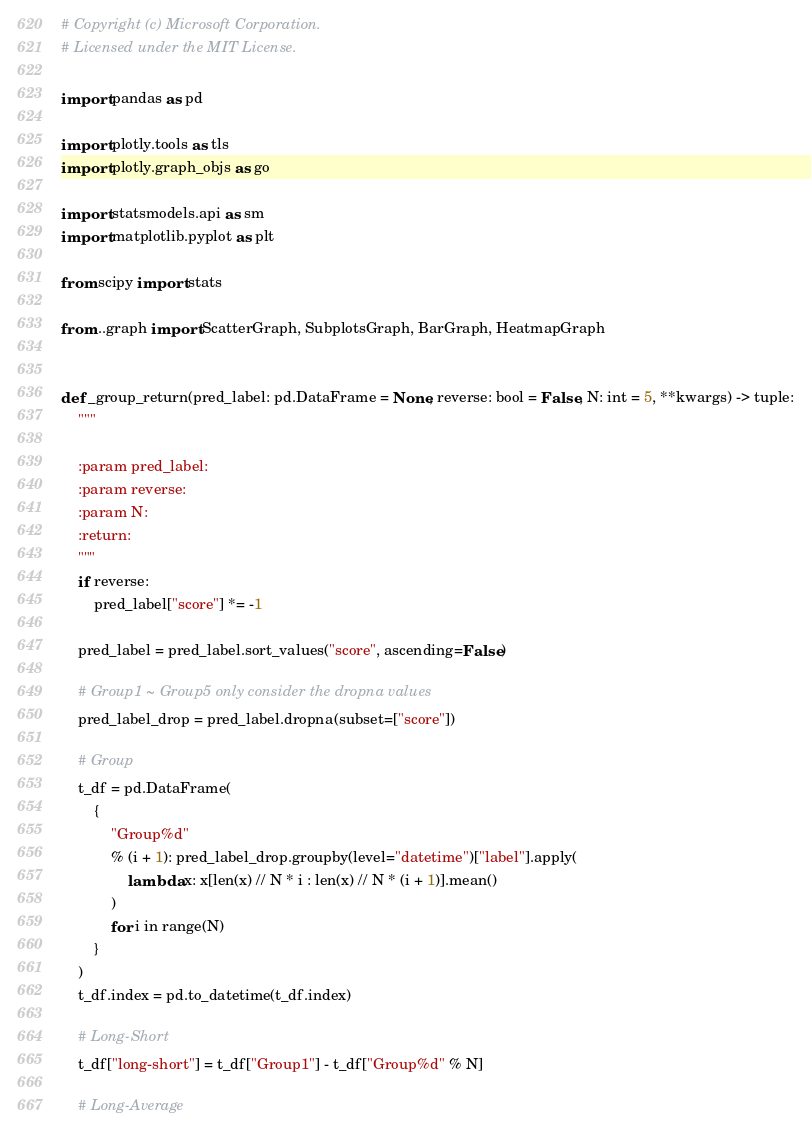Convert code to text. <code><loc_0><loc_0><loc_500><loc_500><_Python_># Copyright (c) Microsoft Corporation.
# Licensed under the MIT License.

import pandas as pd

import plotly.tools as tls
import plotly.graph_objs as go

import statsmodels.api as sm
import matplotlib.pyplot as plt

from scipy import stats

from ..graph import ScatterGraph, SubplotsGraph, BarGraph, HeatmapGraph


def _group_return(pred_label: pd.DataFrame = None, reverse: bool = False, N: int = 5, **kwargs) -> tuple:
    """

    :param pred_label:
    :param reverse:
    :param N:
    :return:
    """
    if reverse:
        pred_label["score"] *= -1

    pred_label = pred_label.sort_values("score", ascending=False)

    # Group1 ~ Group5 only consider the dropna values
    pred_label_drop = pred_label.dropna(subset=["score"])

    # Group
    t_df = pd.DataFrame(
        {
            "Group%d"
            % (i + 1): pred_label_drop.groupby(level="datetime")["label"].apply(
                lambda x: x[len(x) // N * i : len(x) // N * (i + 1)].mean()
            )
            for i in range(N)
        }
    )
    t_df.index = pd.to_datetime(t_df.index)

    # Long-Short
    t_df["long-short"] = t_df["Group1"] - t_df["Group%d" % N]

    # Long-Average</code> 